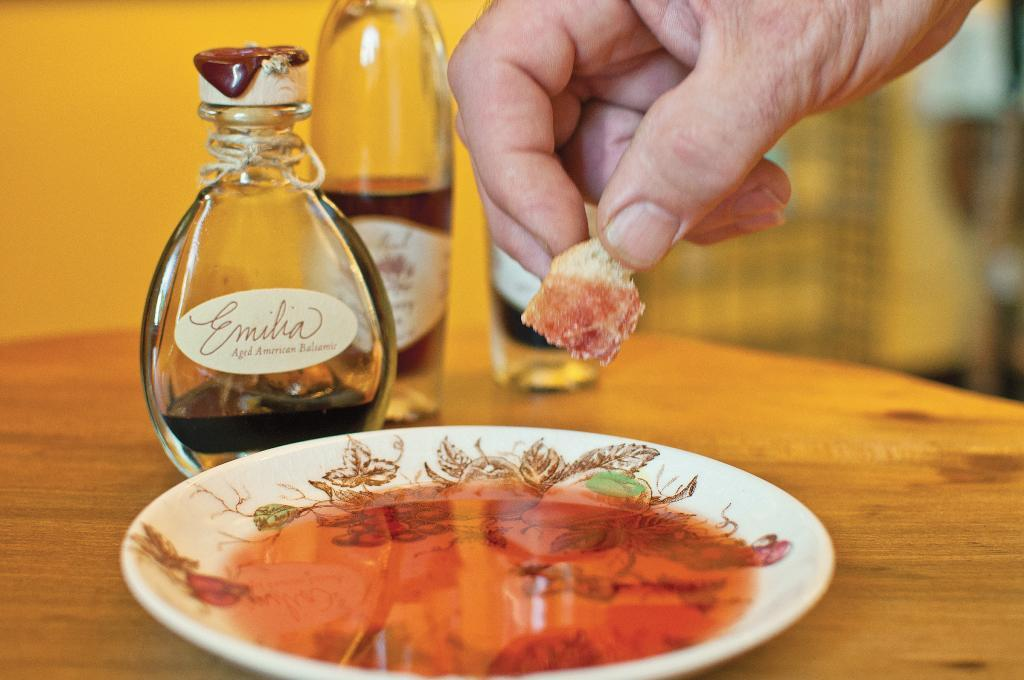<image>
Provide a brief description of the given image. a glass bottle of emilia aged american bailsamir 